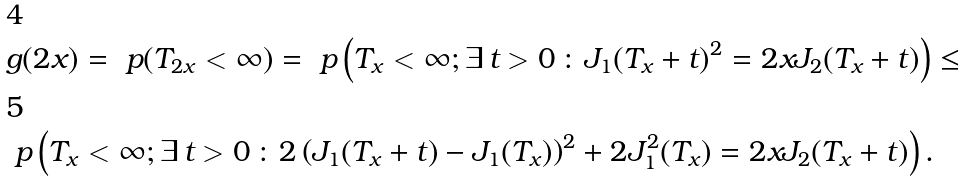<formula> <loc_0><loc_0><loc_500><loc_500>& g ( 2 x ) = \ p ( T _ { 2 x } < \infty ) = \ p \left ( T _ { x } < \infty ; \exists \, t > 0 \, \colon J _ { 1 } ( T _ { x } + t ) ^ { 2 } = 2 x J _ { 2 } ( T _ { x } + t ) \right ) \leq \\ & \ p \left ( T _ { x } < \infty ; \exists \, t > 0 \, \colon 2 \left ( J _ { 1 } ( T _ { x } + t ) - J _ { 1 } ( T _ { x } ) \right ) ^ { 2 } + 2 J ^ { 2 } _ { 1 } ( T _ { x } ) = 2 x J _ { 2 } ( T _ { x } + t ) \right ) .</formula> 